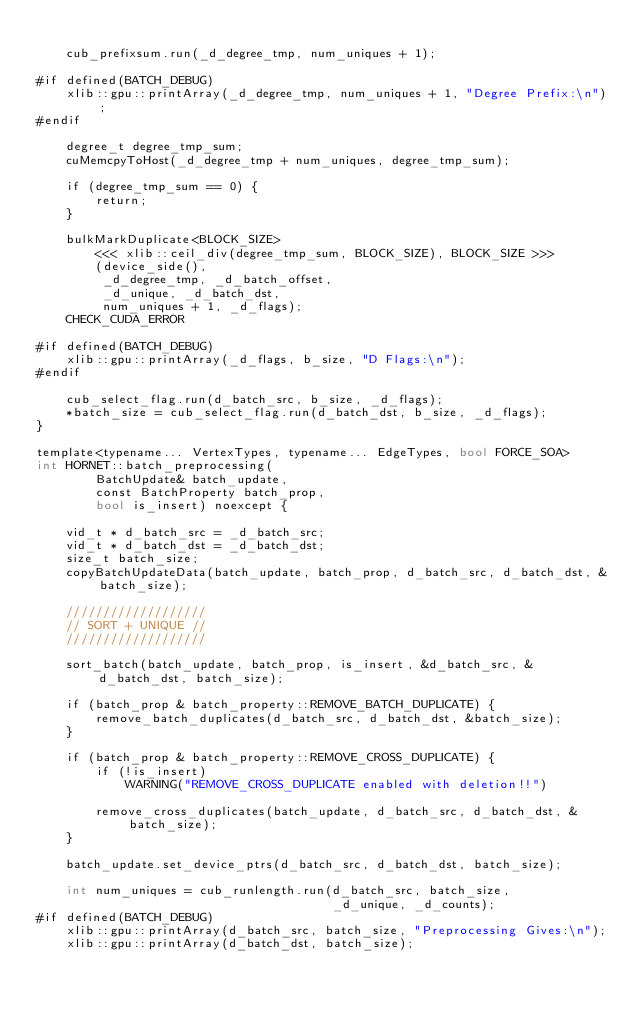<code> <loc_0><loc_0><loc_500><loc_500><_Cuda_>
    cub_prefixsum.run(_d_degree_tmp, num_uniques + 1);

#if defined(BATCH_DEBUG)
    xlib::gpu::printArray(_d_degree_tmp, num_uniques + 1, "Degree Prefix:\n");
#endif

    degree_t degree_tmp_sum;
    cuMemcpyToHost(_d_degree_tmp + num_uniques, degree_tmp_sum);

    if (degree_tmp_sum == 0) {
        return;
    }

    bulkMarkDuplicate<BLOCK_SIZE>
        <<< xlib::ceil_div(degree_tmp_sum, BLOCK_SIZE), BLOCK_SIZE >>>
        (device_side(),
         _d_degree_tmp, _d_batch_offset,
         _d_unique, _d_batch_dst,
         num_uniques + 1, _d_flags);
    CHECK_CUDA_ERROR

#if defined(BATCH_DEBUG)
    xlib::gpu::printArray(_d_flags, b_size, "D Flags:\n");
#endif

    cub_select_flag.run(d_batch_src, b_size, _d_flags);
    *batch_size = cub_select_flag.run(d_batch_dst, b_size, _d_flags);
}

template<typename... VertexTypes, typename... EdgeTypes, bool FORCE_SOA>
int HORNET::batch_preprocessing(
        BatchUpdate& batch_update,
        const BatchProperty batch_prop,
        bool is_insert) noexcept {

    vid_t * d_batch_src = _d_batch_src;
    vid_t * d_batch_dst = _d_batch_dst;
    size_t batch_size;
    copyBatchUpdateData(batch_update, batch_prop, d_batch_src, d_batch_dst, &batch_size);

    ///////////////////
    // SORT + UNIQUE //
    ///////////////////

    sort_batch(batch_update, batch_prop, is_insert, &d_batch_src, &d_batch_dst, batch_size);

    if (batch_prop & batch_property::REMOVE_BATCH_DUPLICATE) {
        remove_batch_duplicates(d_batch_src, d_batch_dst, &batch_size);
    }

    if (batch_prop & batch_property::REMOVE_CROSS_DUPLICATE) {
        if (!is_insert)
            WARNING("REMOVE_CROSS_DUPLICATE enabled with deletion!!")

        remove_cross_duplicates(batch_update, d_batch_src, d_batch_dst, &batch_size);
    }

    batch_update.set_device_ptrs(d_batch_src, d_batch_dst, batch_size);

    int num_uniques = cub_runlength.run(d_batch_src, batch_size,
                                        _d_unique, _d_counts);
#if defined(BATCH_DEBUG)
    xlib::gpu::printArray(d_batch_src, batch_size, "Preprocessing Gives:\n");
    xlib::gpu::printArray(d_batch_dst, batch_size);</code> 